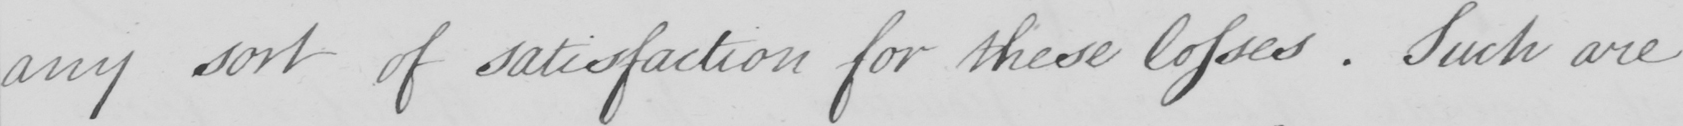Please provide the text content of this handwritten line. any sort of satisfaction for these losses . Such are 